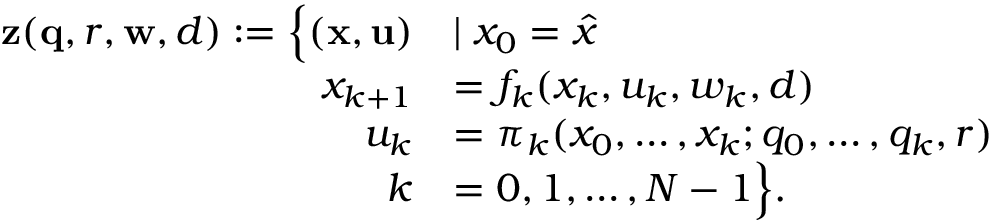Convert formula to latex. <formula><loc_0><loc_0><loc_500><loc_500>\begin{array} { r l } { z ( q , r , w , d ) \colon = \left \{ ( x , u ) } & { | x _ { 0 } = \hat { x } } \\ { x _ { k + 1 } } & { = f _ { k } ( x _ { k } , u _ { k } , w _ { k } , d ) } \\ { u _ { k } } & { = \pi _ { k } ( x _ { 0 } , \dots , x _ { k } ; q _ { 0 } , \dots , q _ { k } , r ) } \\ { k } & { = 0 , 1 , \dots , N - 1 \right \} . } \end{array}</formula> 